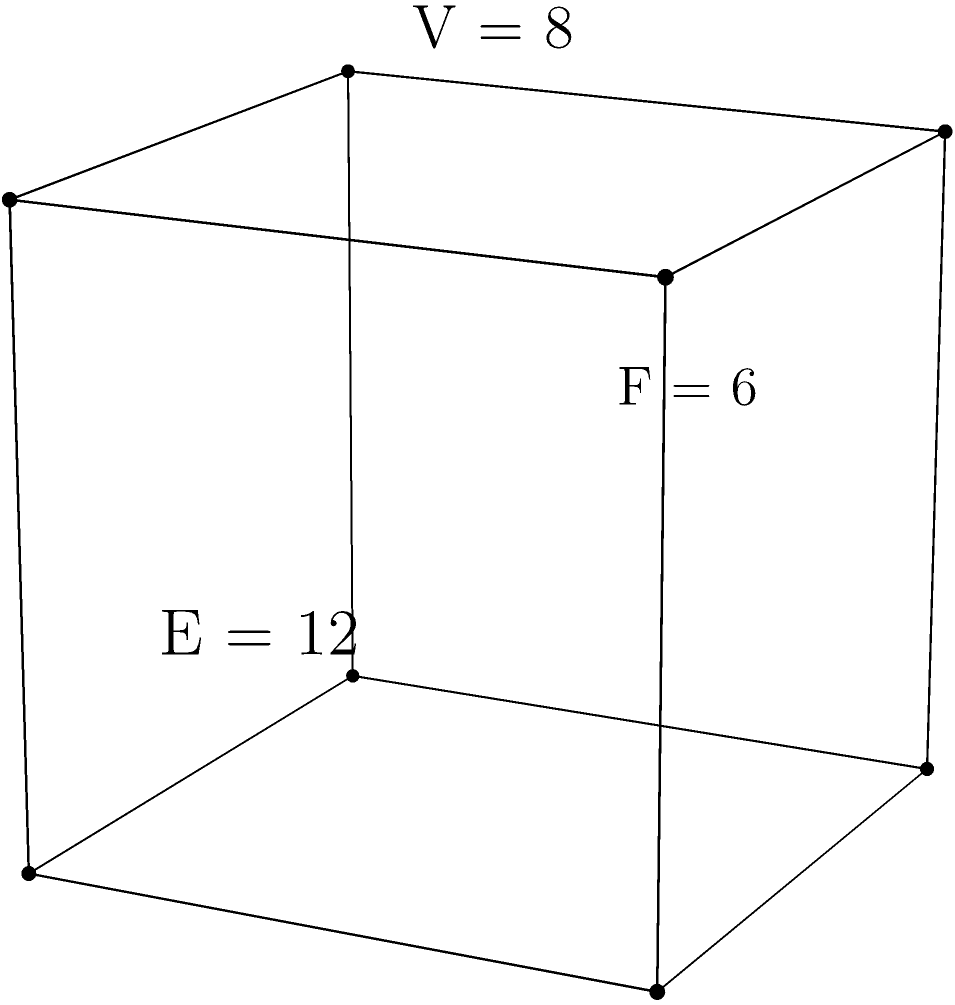Given the cube shown in the figure with 8 vertices, 12 edges, and 6 faces, calculate its Euler characteristic. How does this result relate to the general formula for the Euler characteristic of a polyhedron? To solve this problem, we'll follow these steps:

1) Recall the Euler characteristic formula for polyhedra:
   $$\chi = V - E + F$$
   where $\chi$ is the Euler characteristic, $V$ is the number of vertices, $E$ is the number of edges, and $F$ is the number of faces.

2) From the given information:
   $V = 8$ (vertices)
   $E = 12$ (edges)
   $F = 6$ (faces)

3) Substitute these values into the formula:
   $$\chi = 8 - 12 + 6$$

4) Calculate:
   $$\chi = 2$$

5) Relation to the general formula:
   The Euler characteristic of 2 is a constant for all convex polyhedra and for any polyhedron topologically equivalent to a sphere. This result demonstrates that the cube, despite its specific shape, adheres to the general theorem that states: for any convex polyhedron, the Euler characteristic is always 2.

This example illustrates how the Euler characteristic remains invariant under continuous deformations of the surface, a key concept in topology. It's a fundamental property that holds true not just for cubes, but for all simple (genus 0) polyhedra.
Answer: $\chi = 2$ 